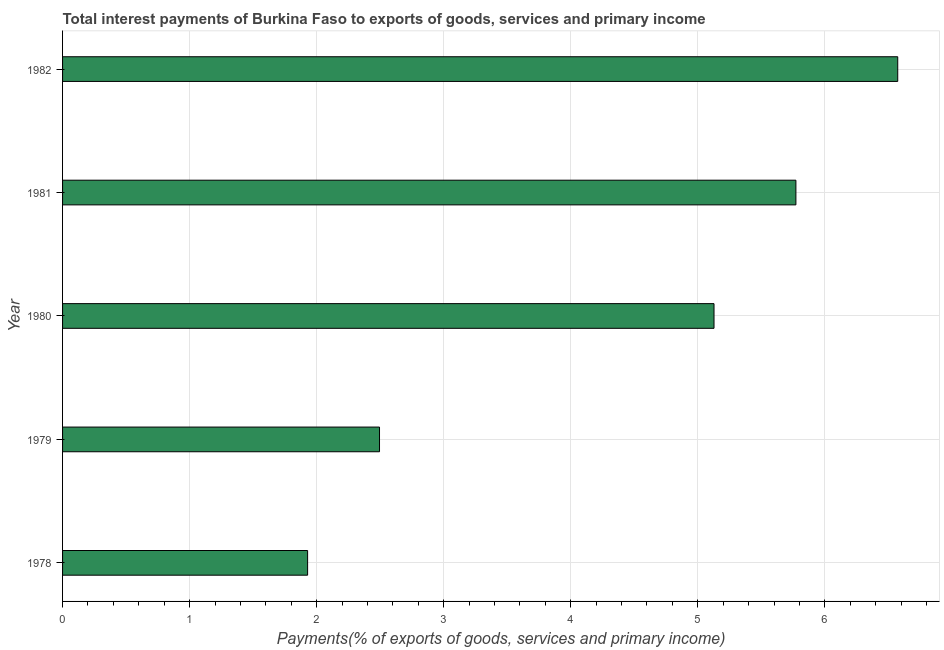Does the graph contain any zero values?
Your answer should be compact. No. Does the graph contain grids?
Ensure brevity in your answer.  Yes. What is the title of the graph?
Your answer should be compact. Total interest payments of Burkina Faso to exports of goods, services and primary income. What is the label or title of the X-axis?
Make the answer very short. Payments(% of exports of goods, services and primary income). What is the total interest payments on external debt in 1982?
Your answer should be compact. 6.57. Across all years, what is the maximum total interest payments on external debt?
Provide a short and direct response. 6.57. Across all years, what is the minimum total interest payments on external debt?
Your response must be concise. 1.93. In which year was the total interest payments on external debt minimum?
Make the answer very short. 1978. What is the sum of the total interest payments on external debt?
Give a very brief answer. 21.9. What is the difference between the total interest payments on external debt in 1978 and 1979?
Offer a very short reply. -0.57. What is the average total interest payments on external debt per year?
Your response must be concise. 4.38. What is the median total interest payments on external debt?
Keep it short and to the point. 5.13. In how many years, is the total interest payments on external debt greater than 4.4 %?
Provide a short and direct response. 3. Do a majority of the years between 1979 and 1981 (inclusive) have total interest payments on external debt greater than 3 %?
Provide a short and direct response. Yes. What is the ratio of the total interest payments on external debt in 1978 to that in 1981?
Provide a short and direct response. 0.33. Is the difference between the total interest payments on external debt in 1981 and 1982 greater than the difference between any two years?
Provide a succinct answer. No. What is the difference between the highest and the second highest total interest payments on external debt?
Your response must be concise. 0.8. Is the sum of the total interest payments on external debt in 1978 and 1982 greater than the maximum total interest payments on external debt across all years?
Ensure brevity in your answer.  Yes. What is the difference between the highest and the lowest total interest payments on external debt?
Ensure brevity in your answer.  4.65. In how many years, is the total interest payments on external debt greater than the average total interest payments on external debt taken over all years?
Ensure brevity in your answer.  3. How many bars are there?
Provide a succinct answer. 5. Are all the bars in the graph horizontal?
Give a very brief answer. Yes. What is the difference between two consecutive major ticks on the X-axis?
Your answer should be compact. 1. What is the Payments(% of exports of goods, services and primary income) of 1978?
Ensure brevity in your answer.  1.93. What is the Payments(% of exports of goods, services and primary income) of 1979?
Offer a terse response. 2.49. What is the Payments(% of exports of goods, services and primary income) in 1980?
Your answer should be compact. 5.13. What is the Payments(% of exports of goods, services and primary income) of 1981?
Your answer should be very brief. 5.77. What is the Payments(% of exports of goods, services and primary income) in 1982?
Offer a very short reply. 6.57. What is the difference between the Payments(% of exports of goods, services and primary income) in 1978 and 1979?
Make the answer very short. -0.57. What is the difference between the Payments(% of exports of goods, services and primary income) in 1978 and 1980?
Offer a very short reply. -3.2. What is the difference between the Payments(% of exports of goods, services and primary income) in 1978 and 1981?
Provide a succinct answer. -3.84. What is the difference between the Payments(% of exports of goods, services and primary income) in 1978 and 1982?
Offer a terse response. -4.65. What is the difference between the Payments(% of exports of goods, services and primary income) in 1979 and 1980?
Provide a succinct answer. -2.63. What is the difference between the Payments(% of exports of goods, services and primary income) in 1979 and 1981?
Keep it short and to the point. -3.28. What is the difference between the Payments(% of exports of goods, services and primary income) in 1979 and 1982?
Make the answer very short. -4.08. What is the difference between the Payments(% of exports of goods, services and primary income) in 1980 and 1981?
Give a very brief answer. -0.64. What is the difference between the Payments(% of exports of goods, services and primary income) in 1980 and 1982?
Make the answer very short. -1.45. What is the difference between the Payments(% of exports of goods, services and primary income) in 1981 and 1982?
Ensure brevity in your answer.  -0.8. What is the ratio of the Payments(% of exports of goods, services and primary income) in 1978 to that in 1979?
Your answer should be very brief. 0.77. What is the ratio of the Payments(% of exports of goods, services and primary income) in 1978 to that in 1980?
Ensure brevity in your answer.  0.38. What is the ratio of the Payments(% of exports of goods, services and primary income) in 1978 to that in 1981?
Provide a succinct answer. 0.33. What is the ratio of the Payments(% of exports of goods, services and primary income) in 1978 to that in 1982?
Your response must be concise. 0.29. What is the ratio of the Payments(% of exports of goods, services and primary income) in 1979 to that in 1980?
Your response must be concise. 0.49. What is the ratio of the Payments(% of exports of goods, services and primary income) in 1979 to that in 1981?
Provide a short and direct response. 0.43. What is the ratio of the Payments(% of exports of goods, services and primary income) in 1979 to that in 1982?
Provide a short and direct response. 0.38. What is the ratio of the Payments(% of exports of goods, services and primary income) in 1980 to that in 1981?
Give a very brief answer. 0.89. What is the ratio of the Payments(% of exports of goods, services and primary income) in 1980 to that in 1982?
Give a very brief answer. 0.78. What is the ratio of the Payments(% of exports of goods, services and primary income) in 1981 to that in 1982?
Your response must be concise. 0.88. 